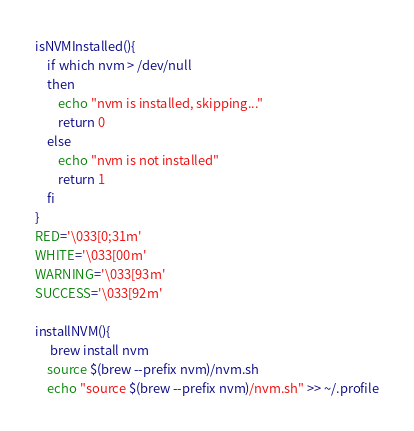<code> <loc_0><loc_0><loc_500><loc_500><_Bash_>isNVMInstalled(){
    if which nvm > /dev/null
    then
        echo "nvm is installed, skipping..."
        return 0
    else
        echo "nvm is not installed"
        return 1
    fi
}
RED='\033[0;31m'
WHITE='\033[00m'
WARNING='\033[93m'
SUCCESS='\033[92m'

installNVM(){
     brew install nvm
    source $(brew --prefix nvm)/nvm.sh
    echo "source $(brew --prefix nvm)/nvm.sh" >> ~/.profile</code> 